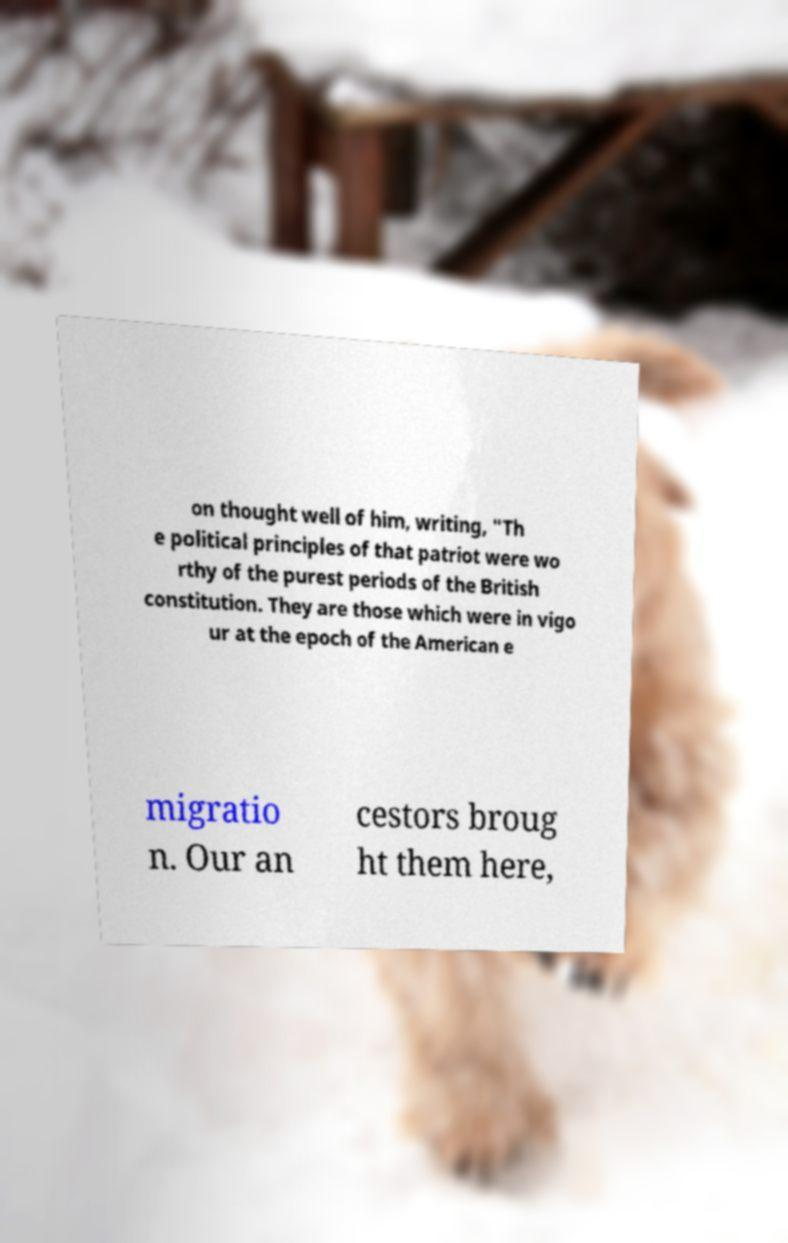What messages or text are displayed in this image? I need them in a readable, typed format. on thought well of him, writing, "Th e political principles of that patriot were wo rthy of the purest periods of the British constitution. They are those which were in vigo ur at the epoch of the American e migratio n. Our an cestors broug ht them here, 